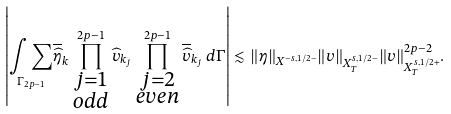Convert formula to latex. <formula><loc_0><loc_0><loc_500><loc_500>\left | \underset { \Gamma _ { 2 p - 1 } } { \int \sum } \overline { \widehat { \eta } } _ { k } \prod _ { \substack { j = 1 \\ o d d } } ^ { 2 p - 1 } \widehat { v } _ { k _ { j } } \prod _ { \substack { j = 2 \\ e v e n } } ^ { 2 p - 1 } \overline { \widehat { v } } _ { k _ { j } } \, d \Gamma \right | \lesssim \| \eta \| _ { X ^ { - s , 1 / 2 - } } \| v \| _ { X ^ { s , 1 / 2 - } _ { T } } \| v \| ^ { 2 p - 2 } _ { X ^ { s , 1 / 2 + } _ { T } } .</formula> 